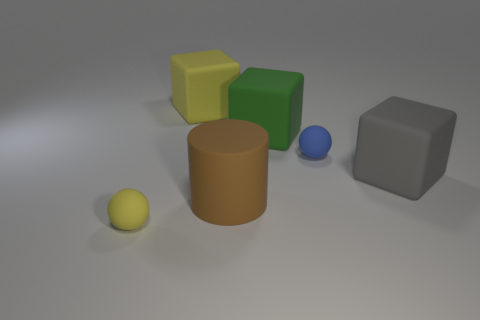Add 3 brown matte cylinders. How many objects exist? 9 Subtract all green cubes. How many cubes are left? 2 Subtract all cylinders. How many objects are left? 5 Subtract all blue things. Subtract all tiny matte balls. How many objects are left? 3 Add 6 large green rubber cubes. How many large green rubber cubes are left? 7 Add 4 cylinders. How many cylinders exist? 5 Subtract 0 purple cylinders. How many objects are left? 6 Subtract all yellow cylinders. Subtract all yellow cubes. How many cylinders are left? 1 